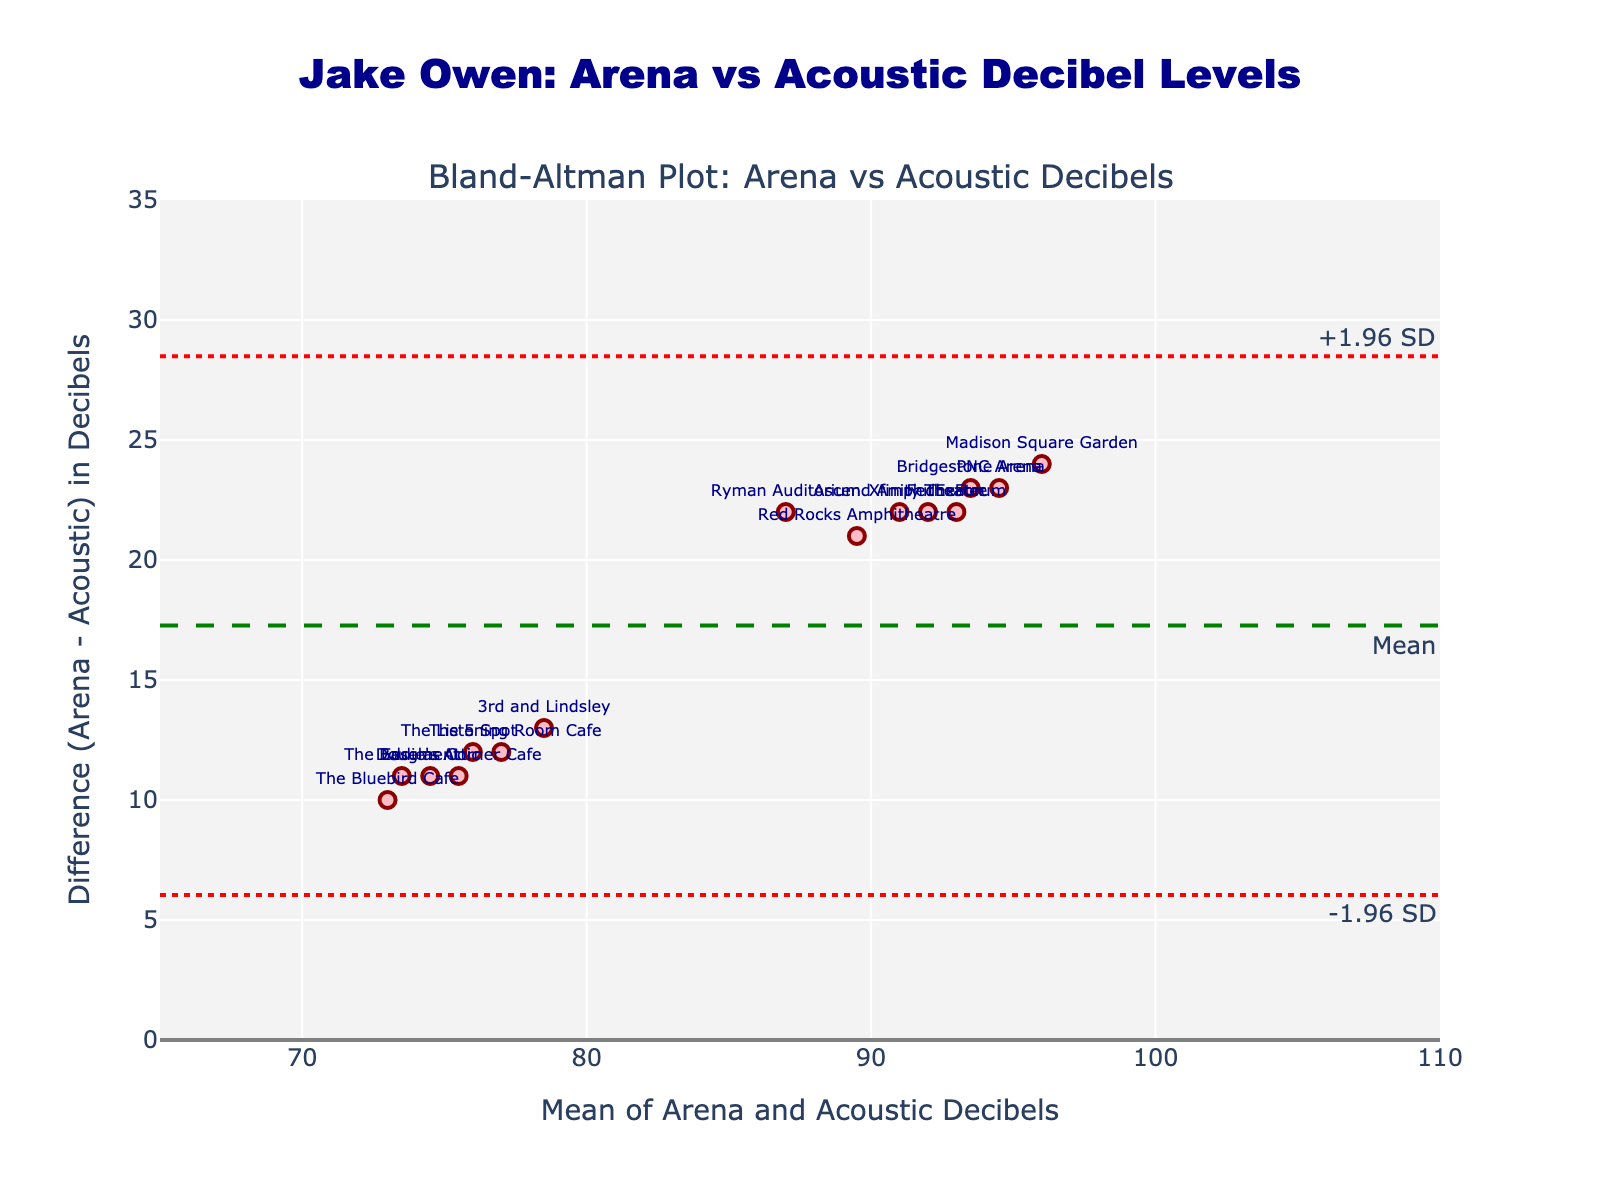Which venue has the highest difference in decibels between arena and acoustic shows? The venue with the highest difference can be identified by looking at the vertical position of the highest data point on the y-axis. In this case, "Madison Square Garden" has the highest difference of 24 decibels.
Answer: Madison Square Garden What is the mean difference in decibels between arena and acoustic shows? To find the mean difference, locate the dashed green horizontal line labeled "Mean". This line represents the average difference between arena and acoustic decibels, which is approximately 22 decibels.
Answer: 22 decibels Are any data points falling outside the limits of agreement? The limits of agreement are the two dotted red lines on the plot. All the data points should be checked to see if any fall outside these lines. In this plot, all data points fall within the limits of agreement.
Answer: No What is the overall range of the x-axis values (Mean of Arena and Acoustic Decibels)? By examining the x-axis, it can be observed that the range goes from approximately 65 to 110 decibels.
Answer: 65 to 110 decibels Which venue has a mean decibel level closest to 91 decibels? To find this, locate the data point nearest to the x-axis value of 91 decibels. The venue closest to this value is "Xfinity Theatre".
Answer: Xfinity Theatre What are the limits of agreement for this Bland-Altman plot? The limits of agreement are calculated as the mean difference ± 1.96 times the standard deviation of the differences. These limits are represented by the dotted red lines and are approximately 14 and 30 decibels.
Answer: 14 and 30 decibels Which venue has the smallest difference in decibel levels between the two settings? The venue with the smallest difference can be identified by finding the data point closest to the x-axis on the plot. "The Bluebird Cafe" has the smallest difference of 10 decibels.
Answer: The Bluebird Cafe How many venues have decibel level differences between 20 and 24 decibels? Count the number of data points that fall between these y-axis values. There are 7 venues ("Ryman Auditorium", "3rd and Lindsley", "Ascend Amphitheater", "Red Rocks Amphitheatre", "PNC Arena", "Xfinity Theatre", "FedExForum") within this range.
Answer: 7 venues 